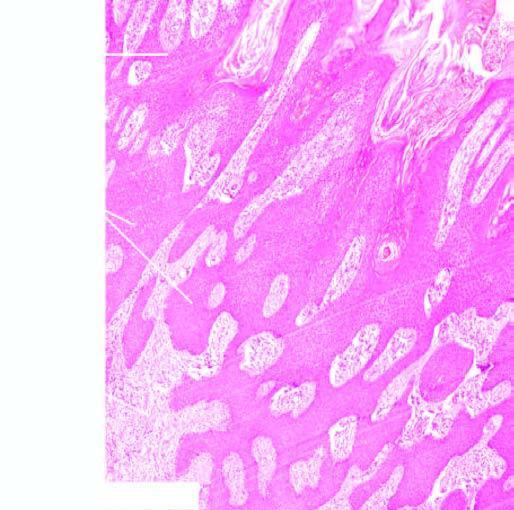does the epidermis show an increase in the number of layers of the squamous epithelium?
Answer the question using a single word or phrase. Yes 